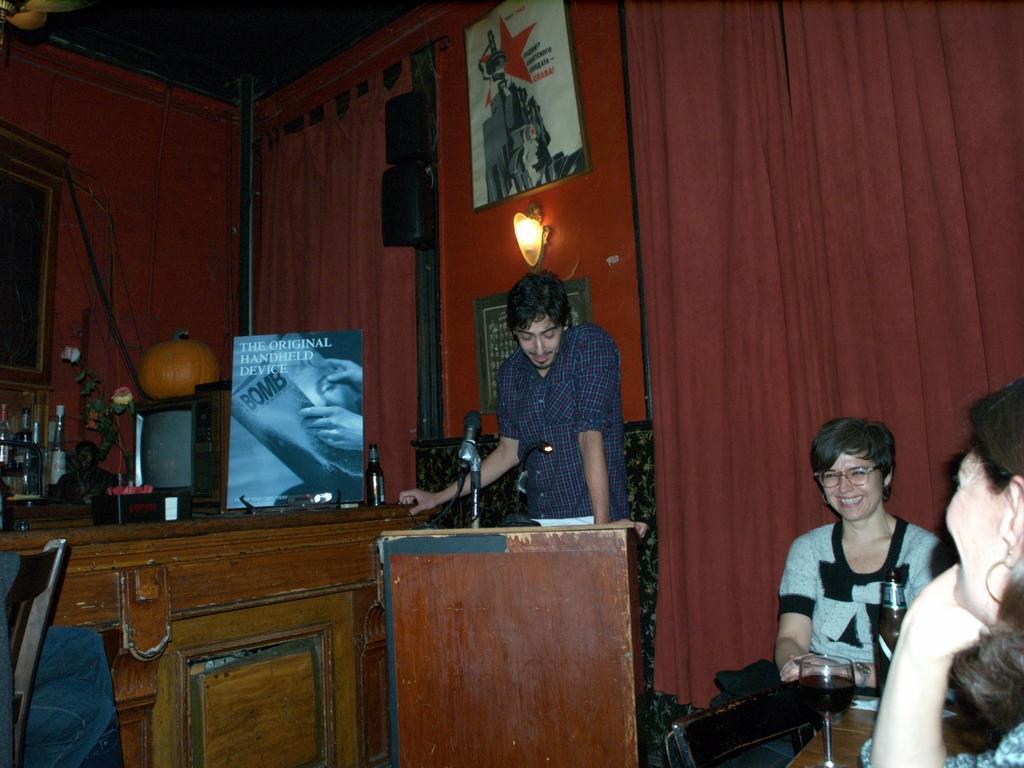Please provide a concise description of this image. In this image a person is standing. Before him there is a podium having a mike. Left side there is a chair before it there is a table having a poster television and few bottles on it. On the television there is a pumpkin. Right side there is a woman. Before her there is a table having a glass on it. Glass is filled with drink. Behind table there is a chair. Beside it there is a woman sitting. She is wearing spectacles. Background there are windows covered with curtains. A lamp is attached to the wall. Left side there is a picture frame attached to the wall. 